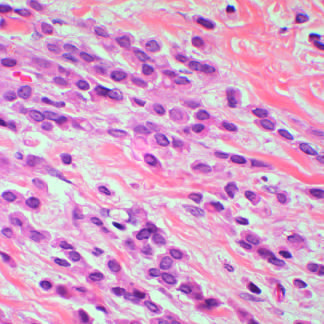what are lobular carcinomas composed of?
Answer the question using a single word or phrase. Noncohesive tumor cells that invade as linear cords of cells and induce little stromal response 